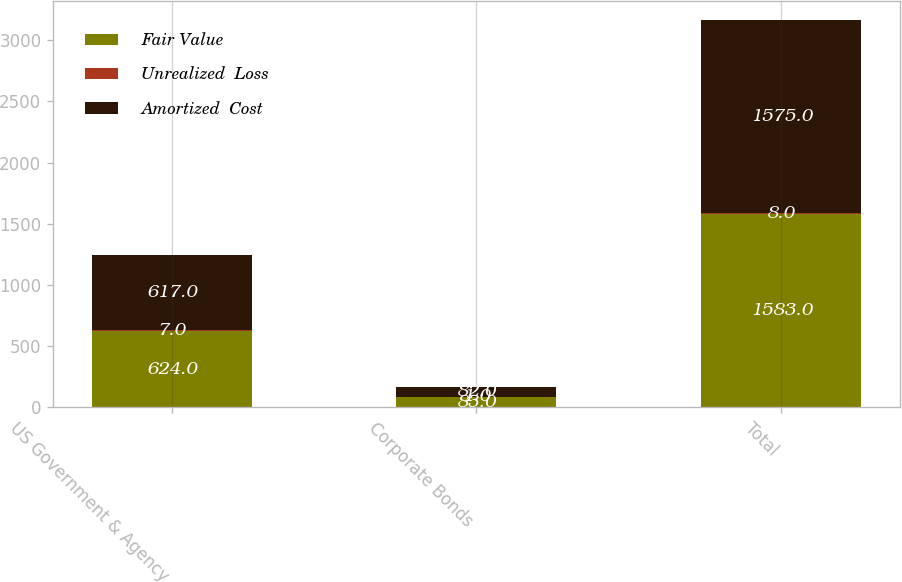<chart> <loc_0><loc_0><loc_500><loc_500><stacked_bar_chart><ecel><fcel>US Government & Agency<fcel>Corporate Bonds<fcel>Total<nl><fcel>Fair Value<fcel>624<fcel>83<fcel>1583<nl><fcel>Unrealized  Loss<fcel>7<fcel>1<fcel>8<nl><fcel>Amortized  Cost<fcel>617<fcel>82<fcel>1575<nl></chart> 